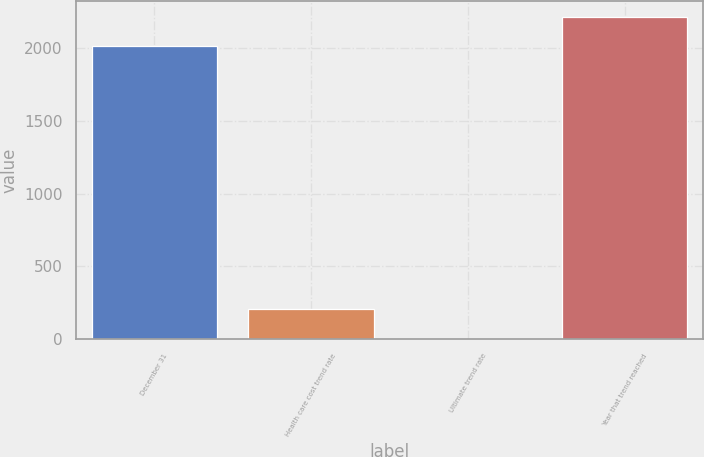Convert chart to OTSL. <chart><loc_0><loc_0><loc_500><loc_500><bar_chart><fcel>December 31<fcel>Health care cost trend rate<fcel>Ultimate trend rate<fcel>Year that trend reached<nl><fcel>2012<fcel>206.3<fcel>5<fcel>2213.3<nl></chart> 